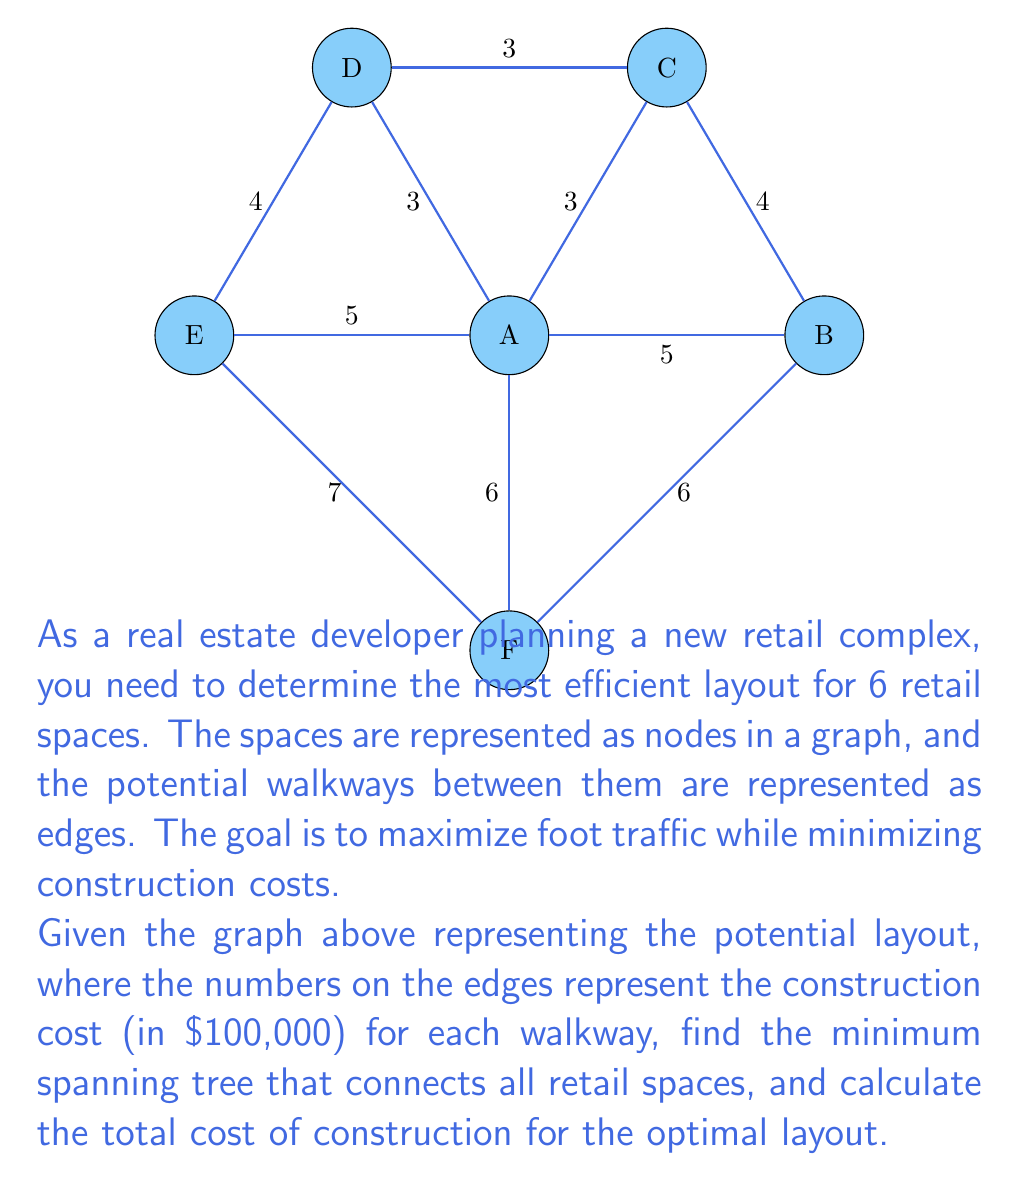Show me your answer to this math problem. To solve this problem, we'll use Kruskal's algorithm to find the minimum spanning tree (MST) of the given graph. This will provide the most efficient layout that connects all retail spaces while minimizing construction costs.

Step 1: Sort all edges by weight (cost) in ascending order:
1. C-D: 3
2. A-C: 3
3. A-D: 3
4. B-C: 4
5. D-E: 4
6. A-B: 5
7. E-A: 5
8. A-F: 6
9. B-F: 6
10. E-F: 7

Step 2: Apply Kruskal's algorithm:
1. Add C-D (3)
2. Add A-C (3)
3. Add A-D (3) - Skip, as it would create a cycle
4. Add B-C (4)
5. Add D-E (4)

At this point, all nodes are connected, and we have our MST.

Step 3: Calculate the total cost:
Total cost = 3 + 3 + 4 + 4 = $1,400,000

The minimum spanning tree consists of the following edges:
1. C-D
2. A-C
3. B-C
4. D-E

This layout ensures all retail spaces are connected while minimizing the construction cost of walkways.
Answer: $1,400,000 